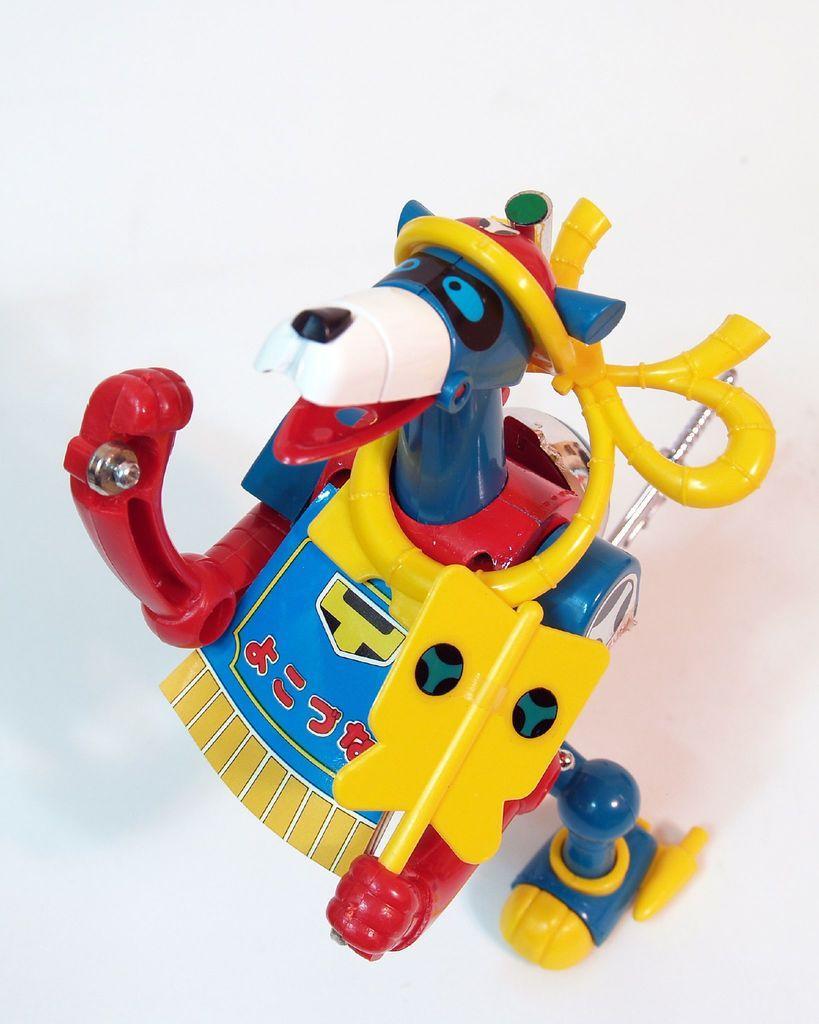How would you summarize this image in a sentence or two? In the foreground of the picture, there is a toy on a white surface. 